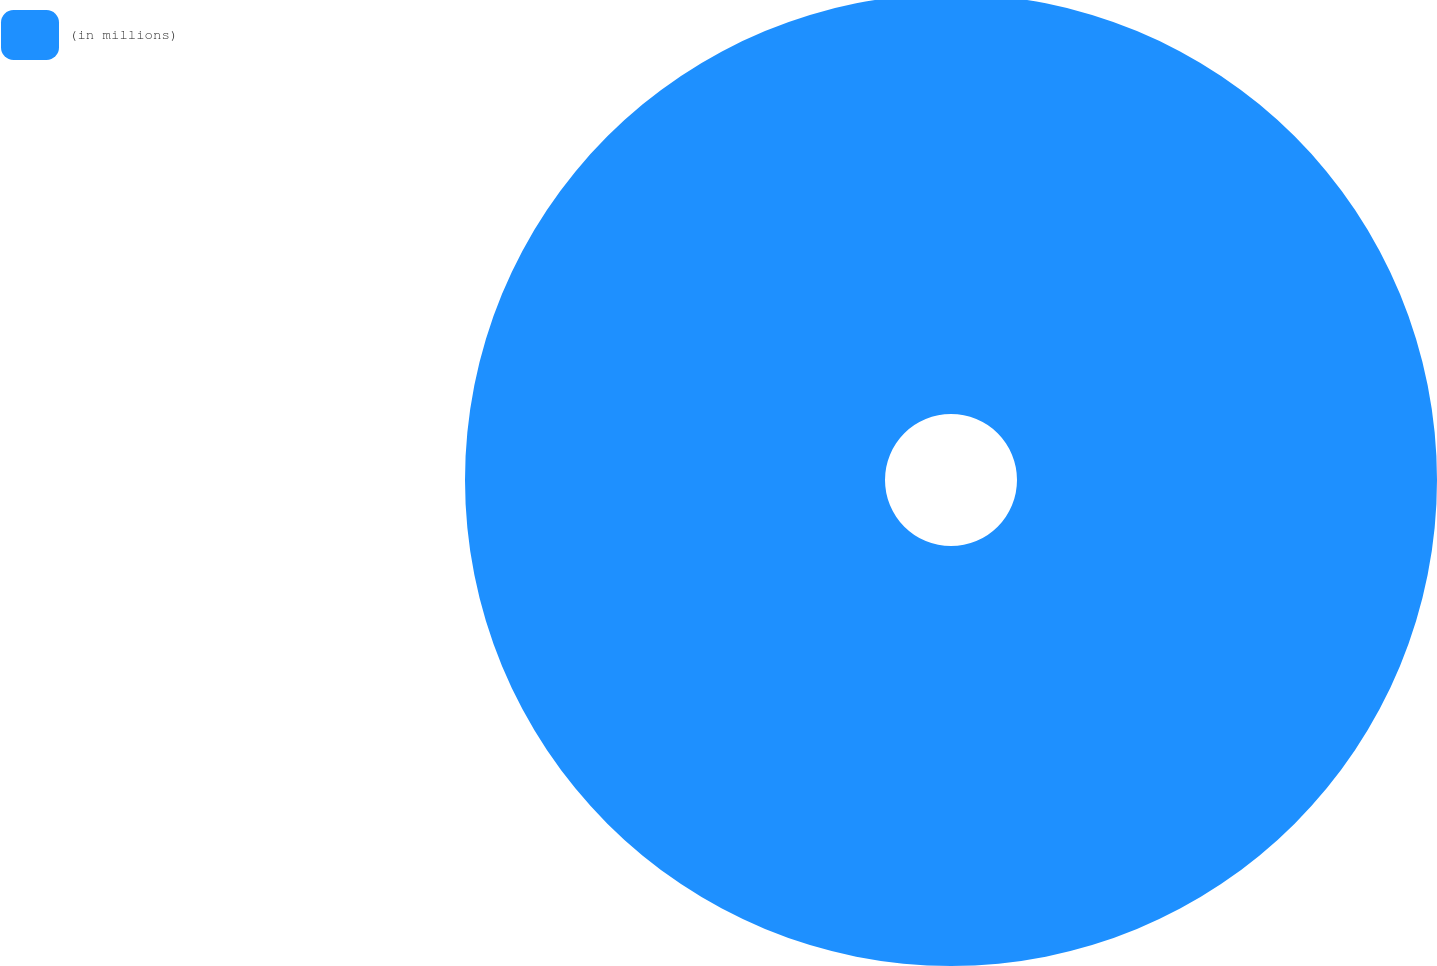Convert chart. <chart><loc_0><loc_0><loc_500><loc_500><pie_chart><fcel>(in millions)<nl><fcel>100.0%<nl></chart> 